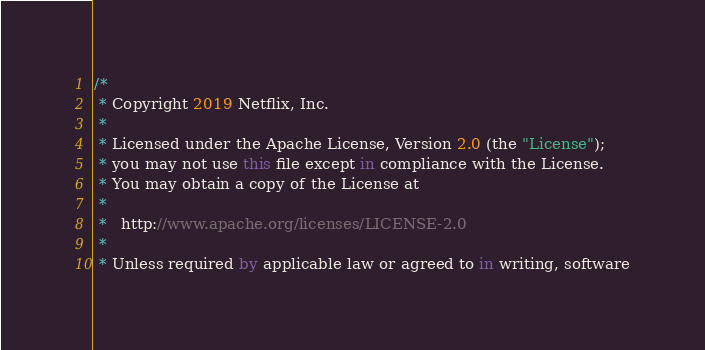Convert code to text. <code><loc_0><loc_0><loc_500><loc_500><_Kotlin_>/*
 * Copyright 2019 Netflix, Inc.
 *
 * Licensed under the Apache License, Version 2.0 (the "License");
 * you may not use this file except in compliance with the License.
 * You may obtain a copy of the License at
 *
 *   http://www.apache.org/licenses/LICENSE-2.0
 *
 * Unless required by applicable law or agreed to in writing, software</code> 